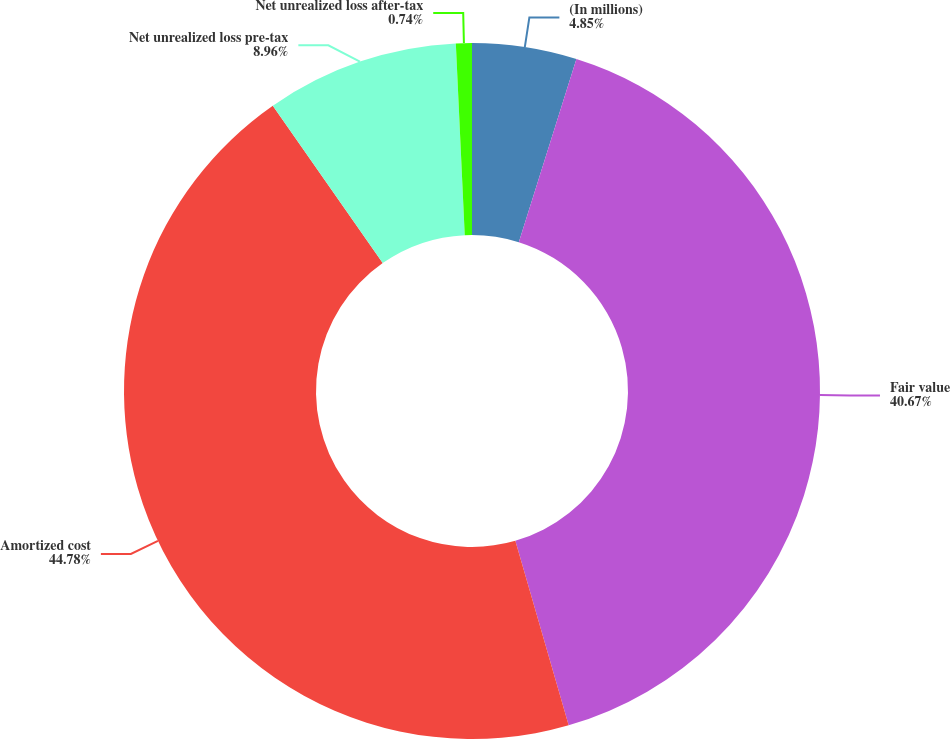Convert chart. <chart><loc_0><loc_0><loc_500><loc_500><pie_chart><fcel>(In millions)<fcel>Fair value<fcel>Amortized cost<fcel>Net unrealized loss pre-tax<fcel>Net unrealized loss after-tax<nl><fcel>4.85%<fcel>40.67%<fcel>44.78%<fcel>8.96%<fcel>0.74%<nl></chart> 